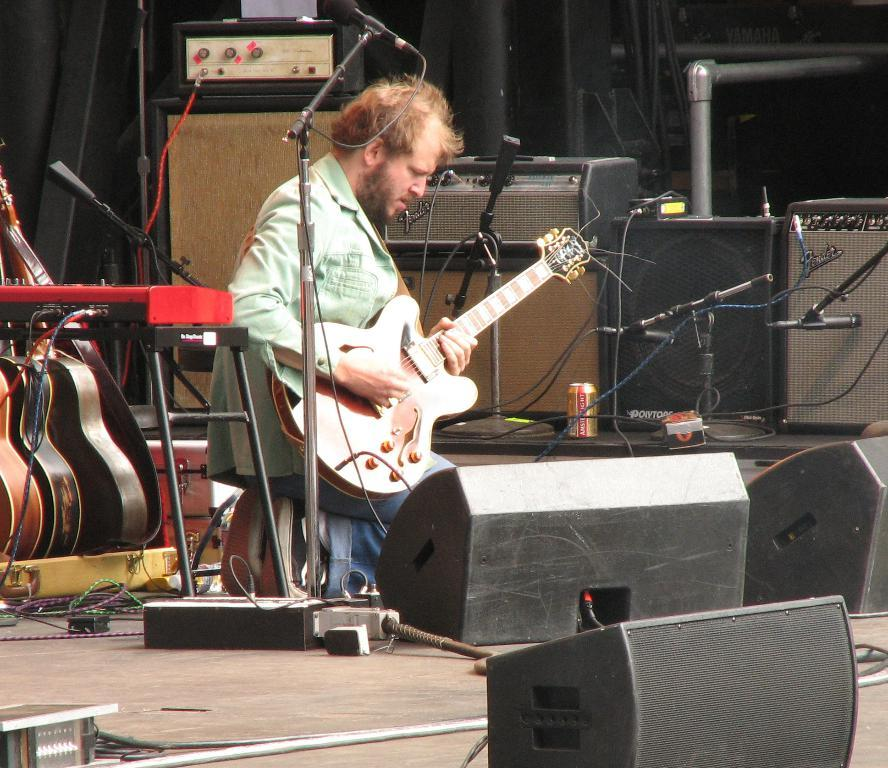Who is the main subject in the image? There is a man in the image. What is the man doing in the image? The man is kneeling and playing a guitar. What other objects are related to music in the image? There is a microphone and musical instruments visible on the man's back. Can you hear the alarm going off in the image? There is no alarm present in the image, so it cannot be heard. 